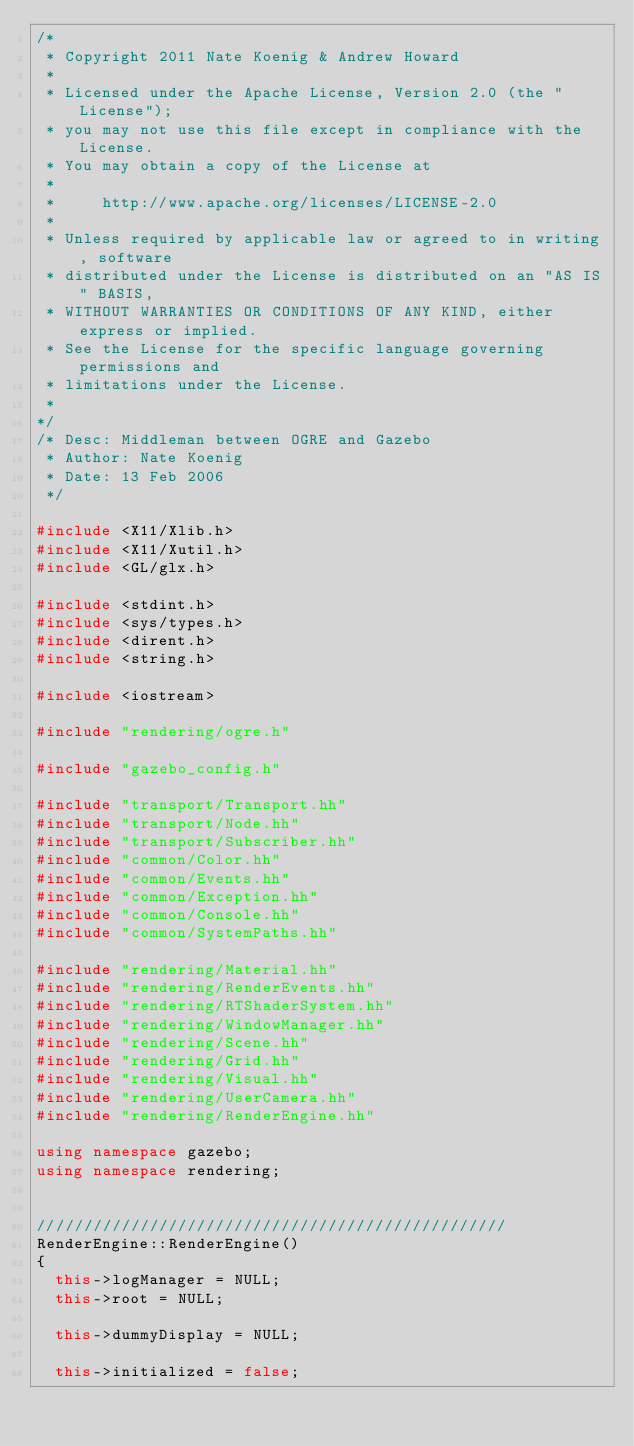<code> <loc_0><loc_0><loc_500><loc_500><_C++_>/*
 * Copyright 2011 Nate Koenig & Andrew Howard
 *
 * Licensed under the Apache License, Version 2.0 (the "License");
 * you may not use this file except in compliance with the License.
 * You may obtain a copy of the License at
 *
 *     http://www.apache.org/licenses/LICENSE-2.0
 *
 * Unless required by applicable law or agreed to in writing, software
 * distributed under the License is distributed on an "AS IS" BASIS,
 * WITHOUT WARRANTIES OR CONDITIONS OF ANY KIND, either express or implied.
 * See the License for the specific language governing permissions and
 * limitations under the License.
 *
*/
/* Desc: Middleman between OGRE and Gazebo
 * Author: Nate Koenig
 * Date: 13 Feb 2006
 */

#include <X11/Xlib.h>
#include <X11/Xutil.h>
#include <GL/glx.h>

#include <stdint.h>
#include <sys/types.h>
#include <dirent.h>
#include <string.h>

#include <iostream>

#include "rendering/ogre.h"

#include "gazebo_config.h"

#include "transport/Transport.hh"
#include "transport/Node.hh"
#include "transport/Subscriber.hh"
#include "common/Color.hh"
#include "common/Events.hh"
#include "common/Exception.hh"
#include "common/Console.hh"
#include "common/SystemPaths.hh"

#include "rendering/Material.hh"
#include "rendering/RenderEvents.hh"
#include "rendering/RTShaderSystem.hh"
#include "rendering/WindowManager.hh"
#include "rendering/Scene.hh"
#include "rendering/Grid.hh"
#include "rendering/Visual.hh"
#include "rendering/UserCamera.hh"
#include "rendering/RenderEngine.hh"

using namespace gazebo;
using namespace rendering;


//////////////////////////////////////////////////
RenderEngine::RenderEngine()
{
  this->logManager = NULL;
  this->root = NULL;

  this->dummyDisplay = NULL;

  this->initialized = false;
</code> 